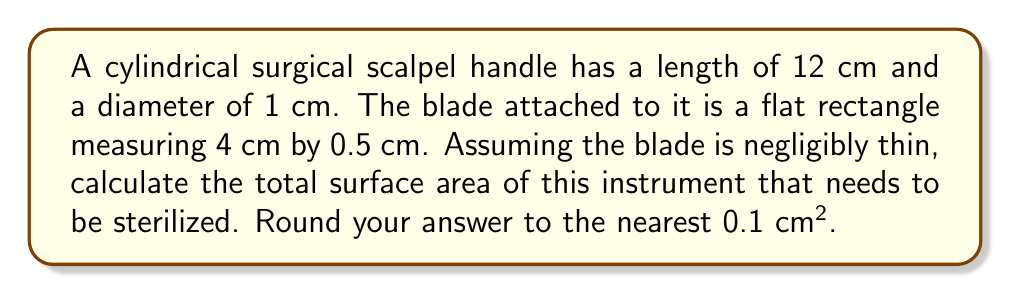Solve this math problem. Let's break this down step-by-step:

1) For the cylindrical handle:
   - Lateral surface area: $A_l = \pi d h$
     where $d$ is diameter and $h$ is height
   - $A_l = \pi (1 \text{ cm}) (12 \text{ cm}) = 12\pi \text{ cm}^2$
   - Circular ends: $A_e = 2 \cdot \frac{1}{4}\pi d^2 = \frac{1}{2}\pi d^2$
   - $A_e = \frac{1}{2}\pi (1 \text{ cm})^2 = \frac{1}{2}\pi \text{ cm}^2$
   
2) Total surface area of handle:
   $A_h = A_l + A_e = 12\pi + \frac{1}{2}\pi = \frac{25}{2}\pi \text{ cm}^2$

3) For the rectangular blade:
   - Area of one side: $A_b = 4 \text{ cm} \cdot 0.5 \text{ cm} = 2 \text{ cm}^2$
   - Total area (both sides): $2A_b = 4 \text{ cm}^2$

4) Total surface area to be sterilized:
   $A_{\text{total}} = A_h + 2A_b = \frac{25}{2}\pi + 4 \text{ cm}^2$

5) Calculating the numerical value:
   $A_{\text{total}} = \frac{25}{2} \cdot 3.14159 + 4 \approx 43.2699 \text{ cm}^2$

6) Rounding to the nearest 0.1 cm²:
   $A_{\text{total}} \approx 43.3 \text{ cm}^2$
Answer: 43.3 cm² 